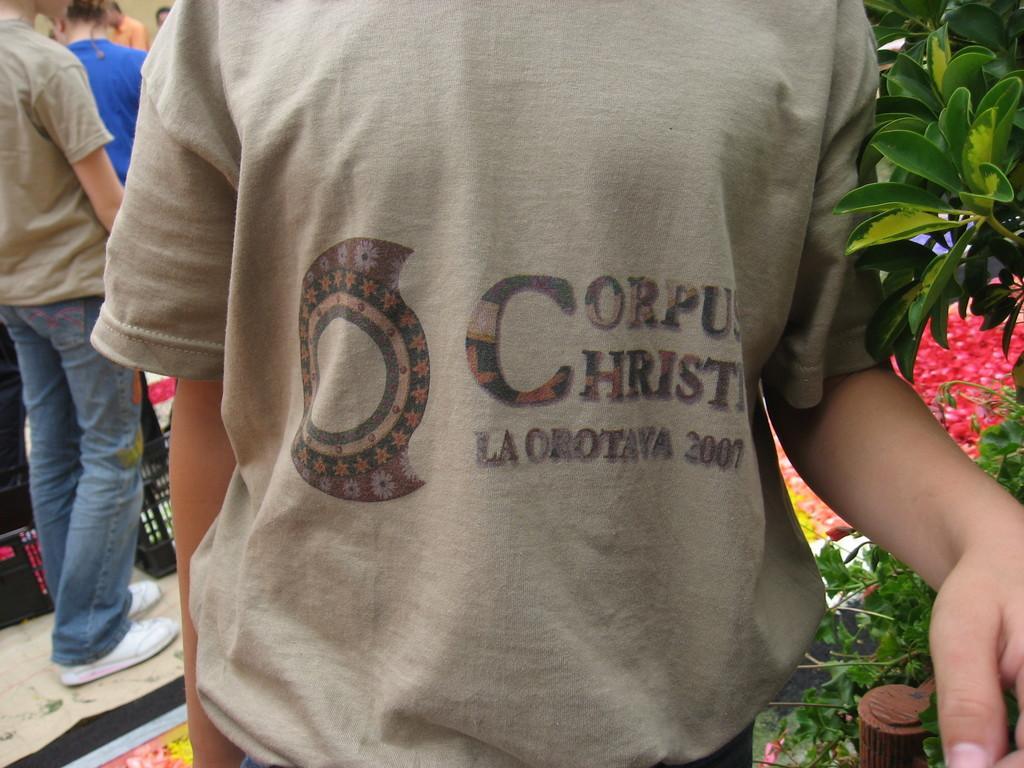In one or two sentences, can you explain what this image depicts? In this picture we can see a group of people standing on the floor, leaves and in the background we can see wall. 